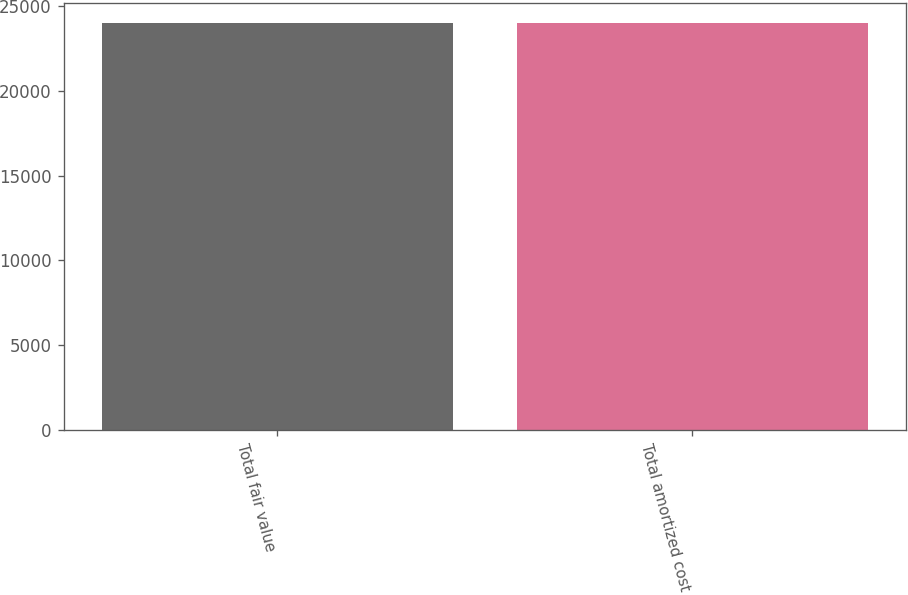<chart> <loc_0><loc_0><loc_500><loc_500><bar_chart><fcel>Total fair value<fcel>Total amortized cost<nl><fcel>23993<fcel>23967<nl></chart> 